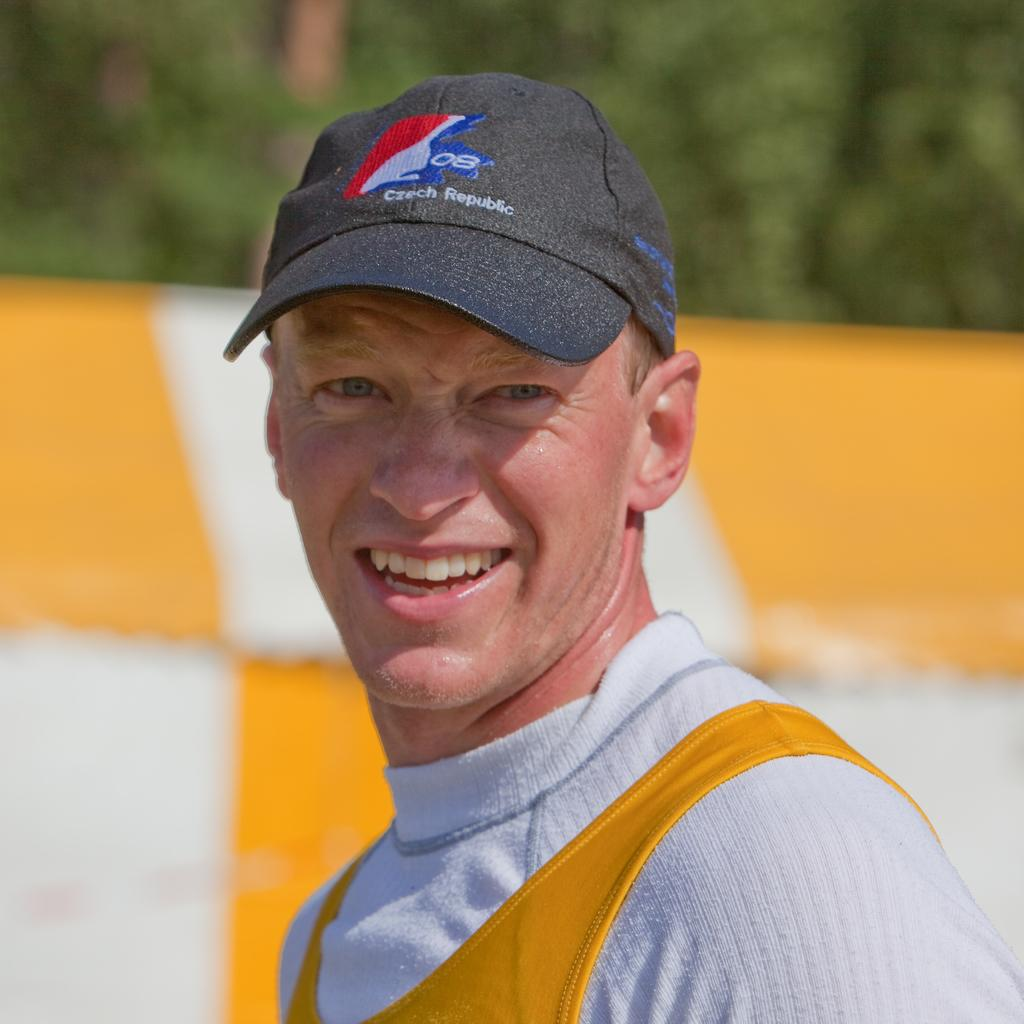<image>
Provide a brief description of the given image. A man wearing a Czech Republic baseball hat smiles. 